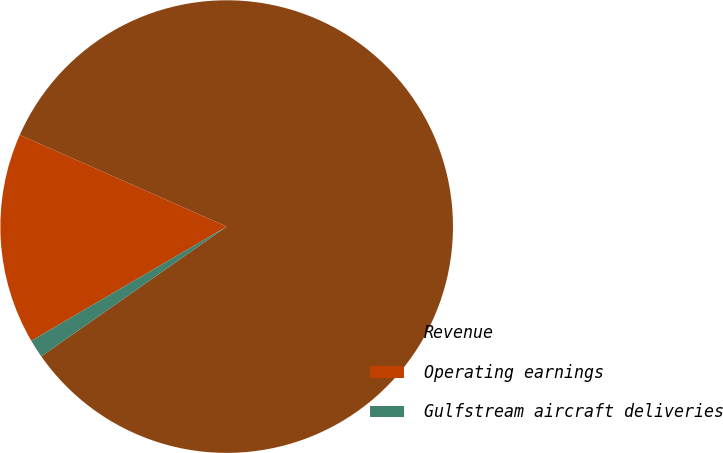Convert chart to OTSL. <chart><loc_0><loc_0><loc_500><loc_500><pie_chart><fcel>Revenue<fcel>Operating earnings<fcel>Gulfstream aircraft deliveries<nl><fcel>83.65%<fcel>15.06%<fcel>1.3%<nl></chart> 